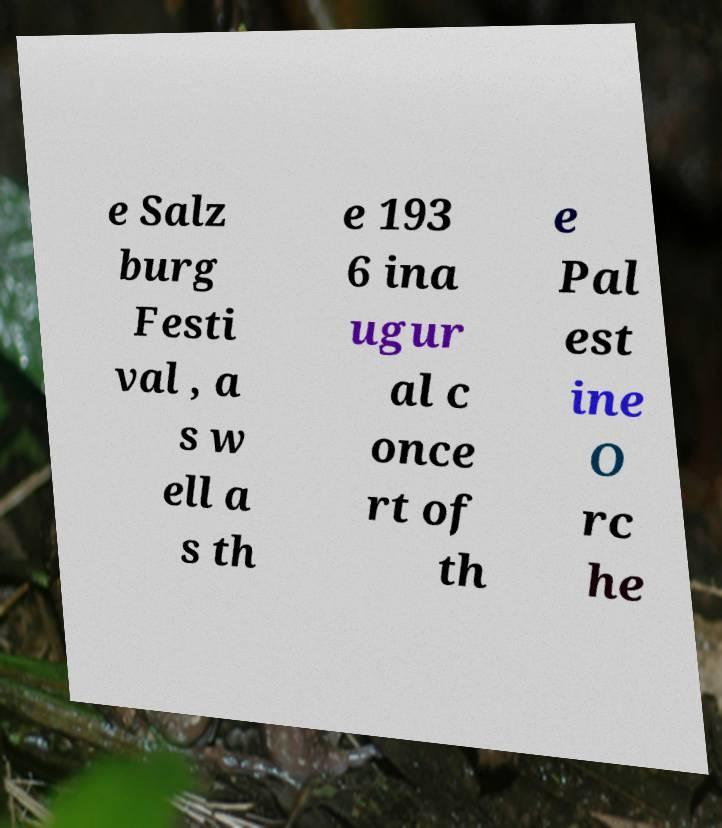Could you extract and type out the text from this image? e Salz burg Festi val , a s w ell a s th e 193 6 ina ugur al c once rt of th e Pal est ine O rc he 